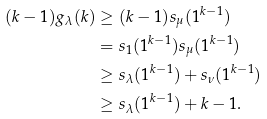<formula> <loc_0><loc_0><loc_500><loc_500>( k - 1 ) g _ { \lambda } ( k ) & \geq ( k - 1 ) s _ { \mu } ( 1 ^ { k - 1 } ) \\ & = s _ { 1 } ( 1 ^ { k - 1 } ) s _ { \mu } ( 1 ^ { k - 1 } ) \\ & \geq s _ { \lambda } ( 1 ^ { k - 1 } ) + s _ { \nu } ( 1 ^ { k - 1 } ) \\ & \geq s _ { \lambda } ( 1 ^ { k - 1 } ) + k - 1 .</formula> 